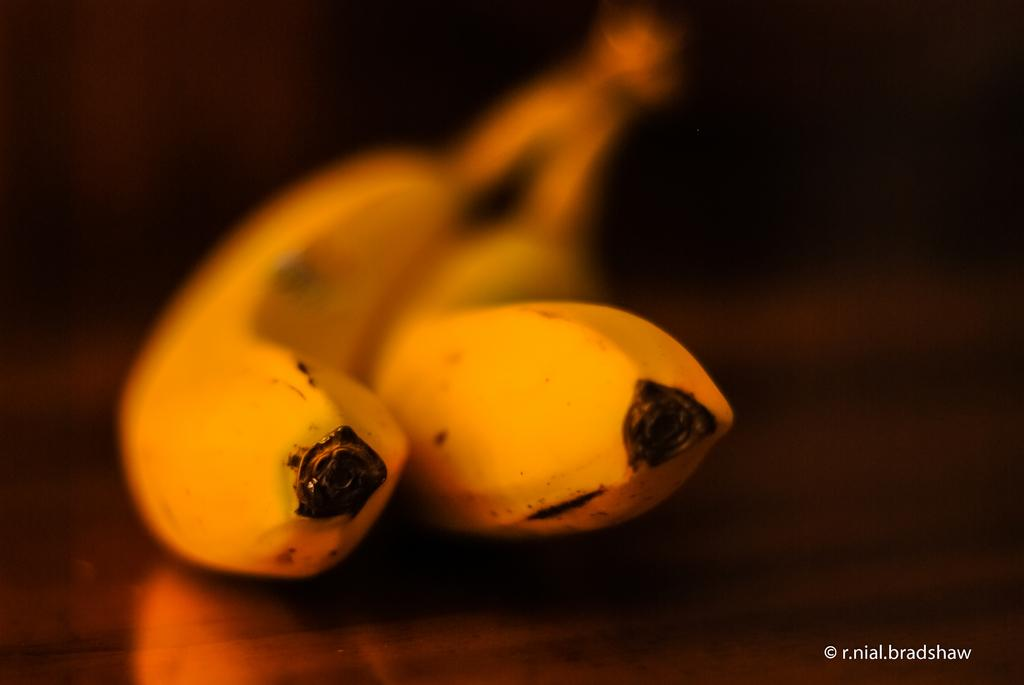What type of fruit can be seen in the image? There are two bananas in the image. What color is the background of the image? The background of the image is black. Is there any text present in the image? Yes, there is edited text in the bottom right corner of the image. What type of quiver can be seen in the image? There is no quiver present in the image. What route is the banana taking in the image? The bananas are stationary in the image and do not appear to be taking any route. 